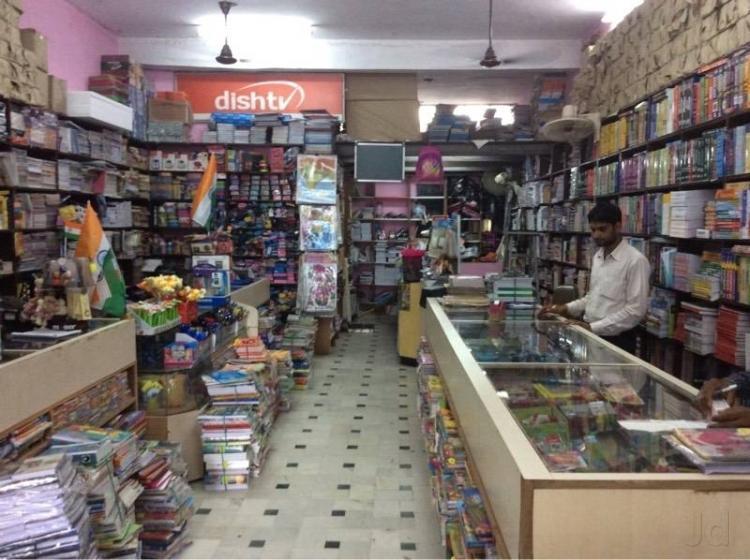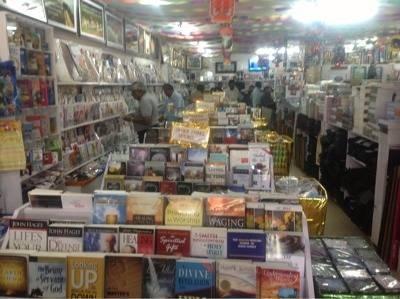The first image is the image on the left, the second image is the image on the right. Considering the images on both sides, is "Both photos show the exterior of a book shop." valid? Answer yes or no. No. 